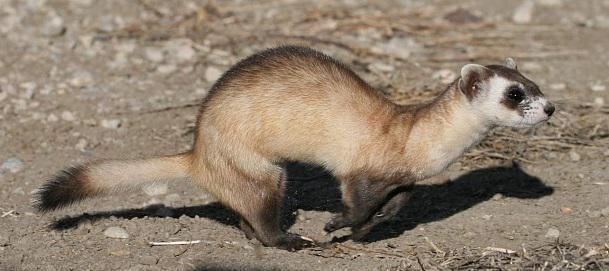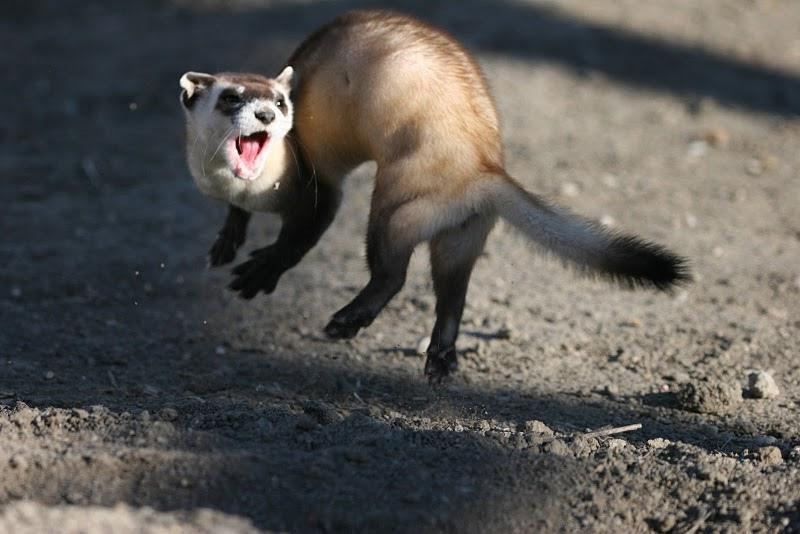The first image is the image on the left, the second image is the image on the right. Examine the images to the left and right. Is the description "The left and right image contains the same number of small rodents." accurate? Answer yes or no. Yes. The first image is the image on the left, the second image is the image on the right. Examine the images to the left and right. Is the description "There is at least one ferret in a hole." accurate? Answer yes or no. No. 